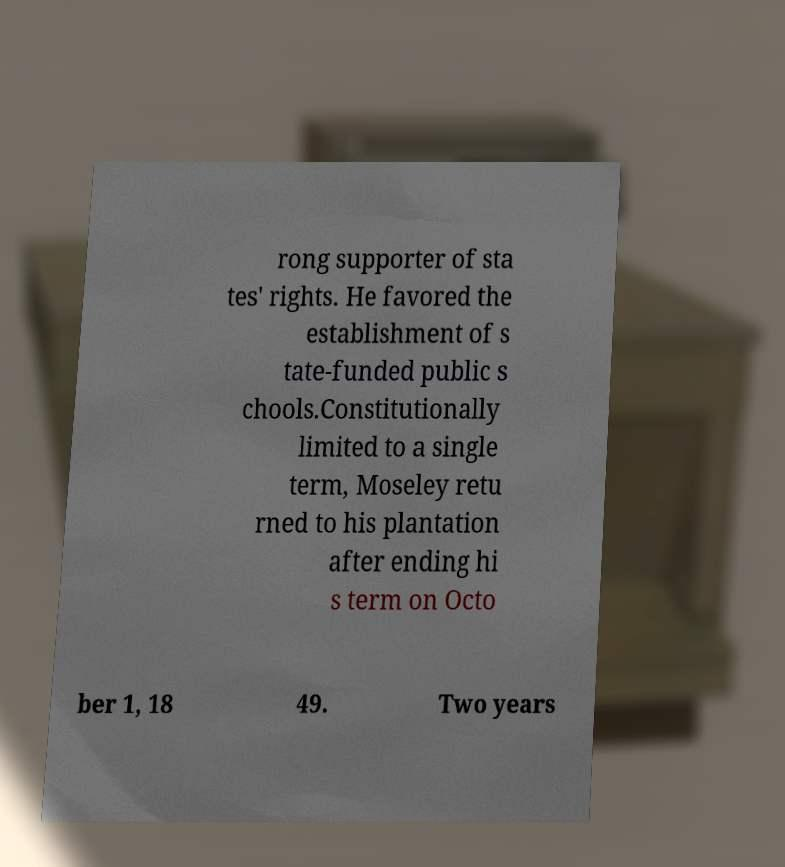I need the written content from this picture converted into text. Can you do that? rong supporter of sta tes' rights. He favored the establishment of s tate-funded public s chools.Constitutionally limited to a single term, Moseley retu rned to his plantation after ending hi s term on Octo ber 1, 18 49. Two years 